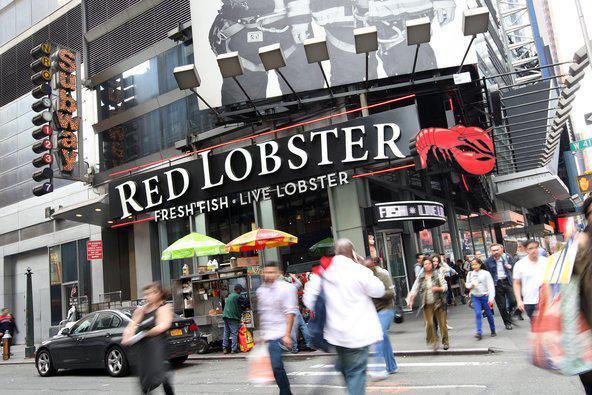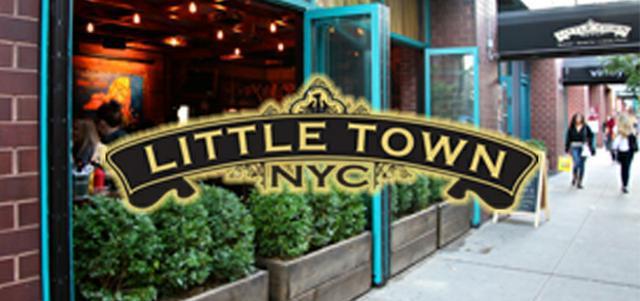The first image is the image on the left, the second image is the image on the right. Analyze the images presented: Is the assertion "There are at least four yellow taxi cabs." valid? Answer yes or no. No. The first image is the image on the left, the second image is the image on the right. For the images shown, is this caption "It is night in the right image, with lots of lit up buildings." true? Answer yes or no. No. 